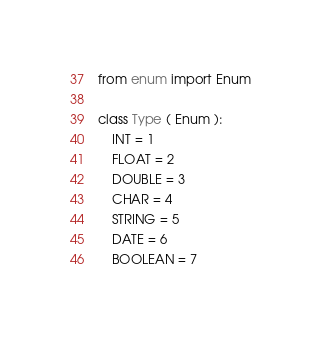Convert code to text. <code><loc_0><loc_0><loc_500><loc_500><_Python_>from enum import Enum

class Type ( Enum ):
    INT = 1
    FLOAT = 2
    DOUBLE = 3
    CHAR = 4
    STRING = 5
    DATE = 6
    BOOLEAN = 7
</code> 